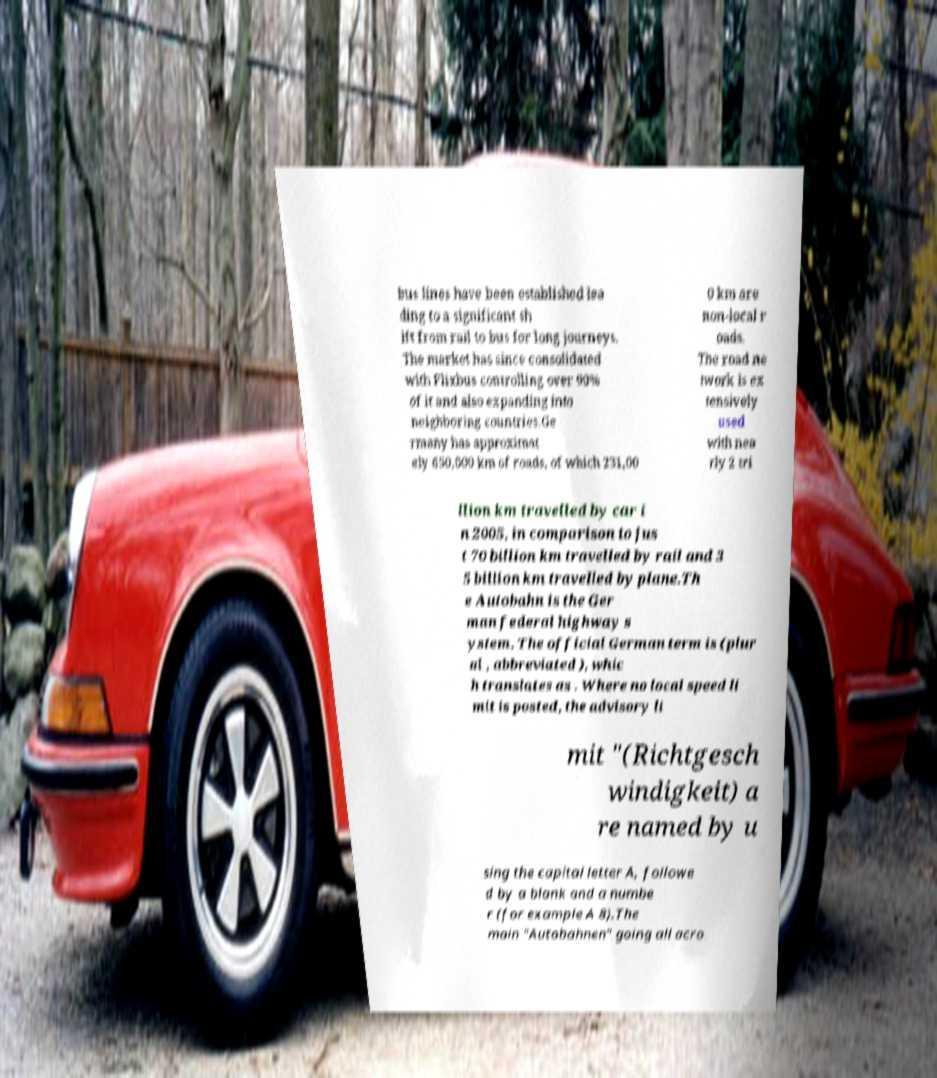What messages or text are displayed in this image? I need them in a readable, typed format. bus lines have been established lea ding to a significant sh ift from rail to bus for long journeys. The market has since consolidated with Flixbus controlling over 90% of it and also expanding into neighboring countries.Ge rmany has approximat ely 650,000 km of roads, of which 231,00 0 km are non-local r oads. The road ne twork is ex tensively used with nea rly 2 tri llion km travelled by car i n 2005, in comparison to jus t 70 billion km travelled by rail and 3 5 billion km travelled by plane.Th e Autobahn is the Ger man federal highway s ystem. The official German term is (plur al , abbreviated ), whic h translates as . Where no local speed li mit is posted, the advisory li mit "(Richtgesch windigkeit) a re named by u sing the capital letter A, followe d by a blank and a numbe r (for example A 8).The main "Autobahnen" going all acro 